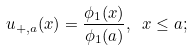<formula> <loc_0><loc_0><loc_500><loc_500>u _ { + , a } ( x ) = \frac { \phi _ { 1 } ( x ) } { \phi _ { 1 } ( a ) } , \ x \leq a ;</formula> 